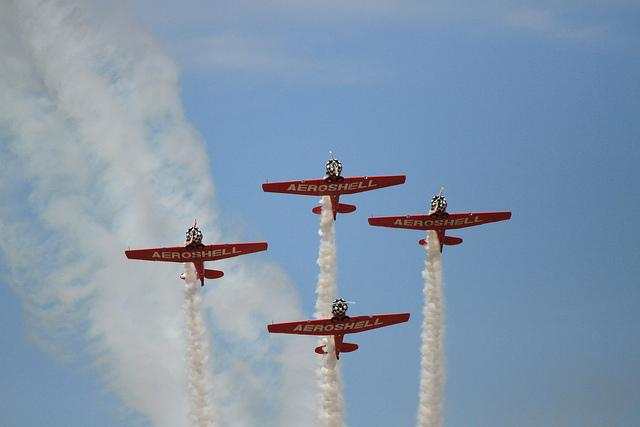What are these planes emitting? smoke 